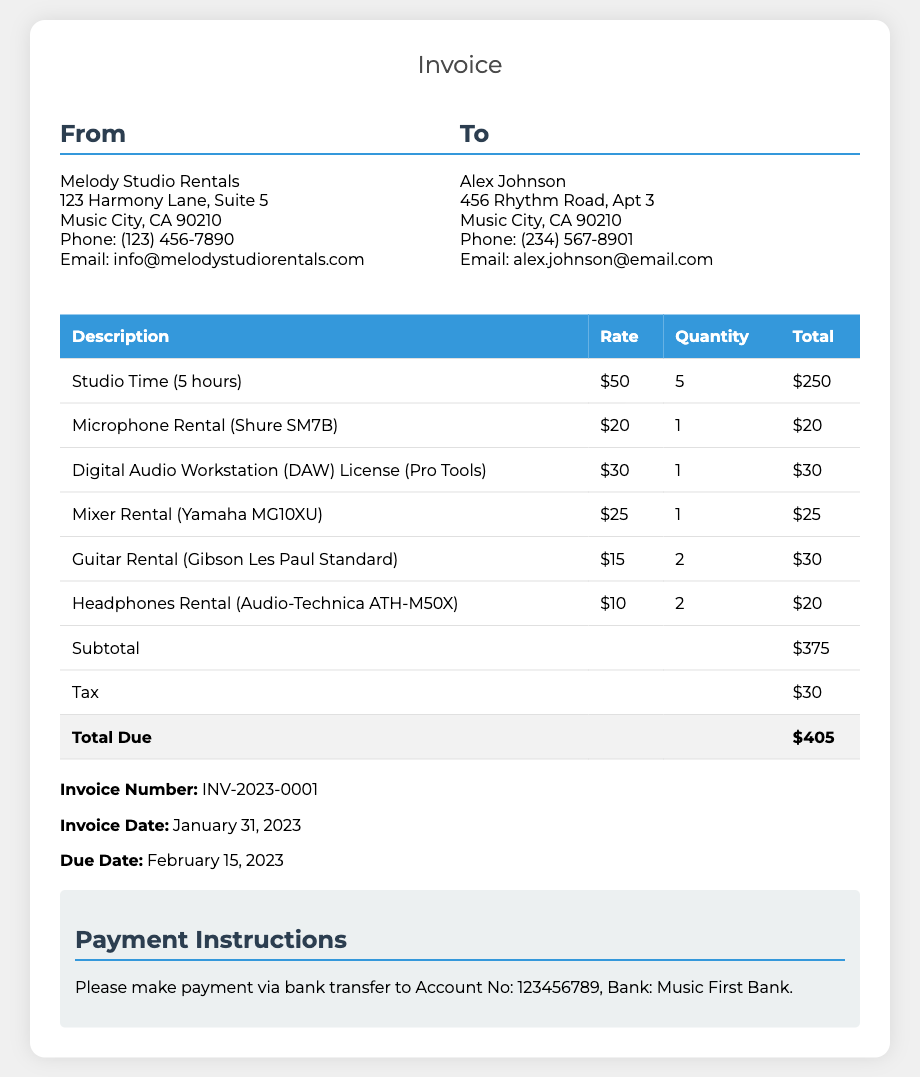What is the invoice number? The invoice number is listed in the document for reference, which is essential for tracking purposes.
Answer: INV-2023-0001 What is the subtotal amount? The subtotal is the sum of all item charges before tax, detailing the costs of services and rentals provided.
Answer: $375 What is the total due amount? The total due includes the subtotal plus any applicable taxes, providing the final amount to be paid by the client.
Answer: $405 How many hours of studio time were charged? The document specifies the amount of studio time used, which calculates the base charge for facility usage.
Answer: 5 hours What is the due date for the invoice? The due date informs the client when payment must be made, which is important for maintaining the account's good standing.
Answer: February 15, 2023 Which microphone was rented? The document provides specific details about the rented equipment, which helps in identifying the gear used during the studio session.
Answer: Shure SM7B What is the tax amount charged on the invoice? The tax amount is listed separately in the document, which shows additional costs incurred on services rendered.
Answer: $30 Who is the client of the invoice? The client information is provided to identify the individual responsible for the payment of the services rendered.
Answer: Alex Johnson What is the total quantity of guitar rentals? The document states the total quantity of specific rentals, which indicates how many of that item were used.
Answer: 2 